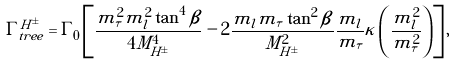Convert formula to latex. <formula><loc_0><loc_0><loc_500><loc_500>\Gamma _ { t r e e } ^ { H ^ { \pm } } = \Gamma _ { 0 } \left [ \frac { m _ { \tau } ^ { 2 } m _ { l } ^ { 2 } \tan ^ { 4 } \beta } { 4 M _ { H ^ { \pm } } ^ { 4 } } - 2 \frac { m _ { l } m _ { \tau } \tan ^ { 2 } \beta } { M _ { H ^ { \pm } } ^ { 2 } } \frac { m _ { l } } { m _ { \tau } } \kappa \left ( \frac { m _ { l } ^ { 2 } } { m _ { \tau } ^ { 2 } } \right ) \right ] ,</formula> 